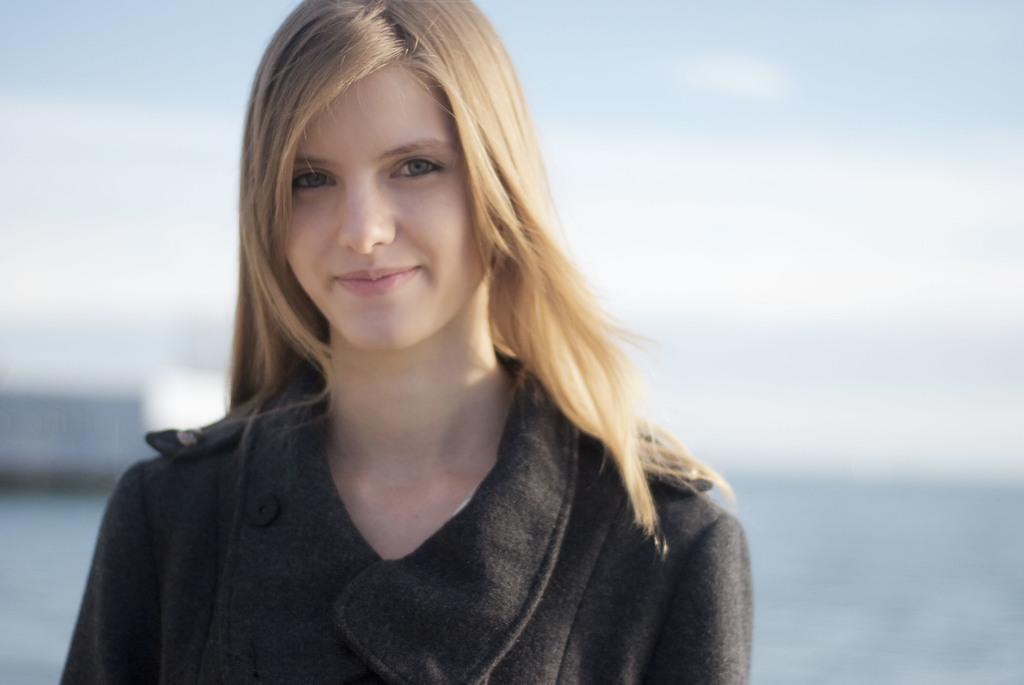Who is the main subject in the image? There is a woman in the image. Where is the woman located in the image? The woman is in the center of the image. What expression does the woman have in the image? The woman is smiling. What type of veil is the woman wearing in the image? There is no veil present in the image; the woman is not wearing any head covering. 